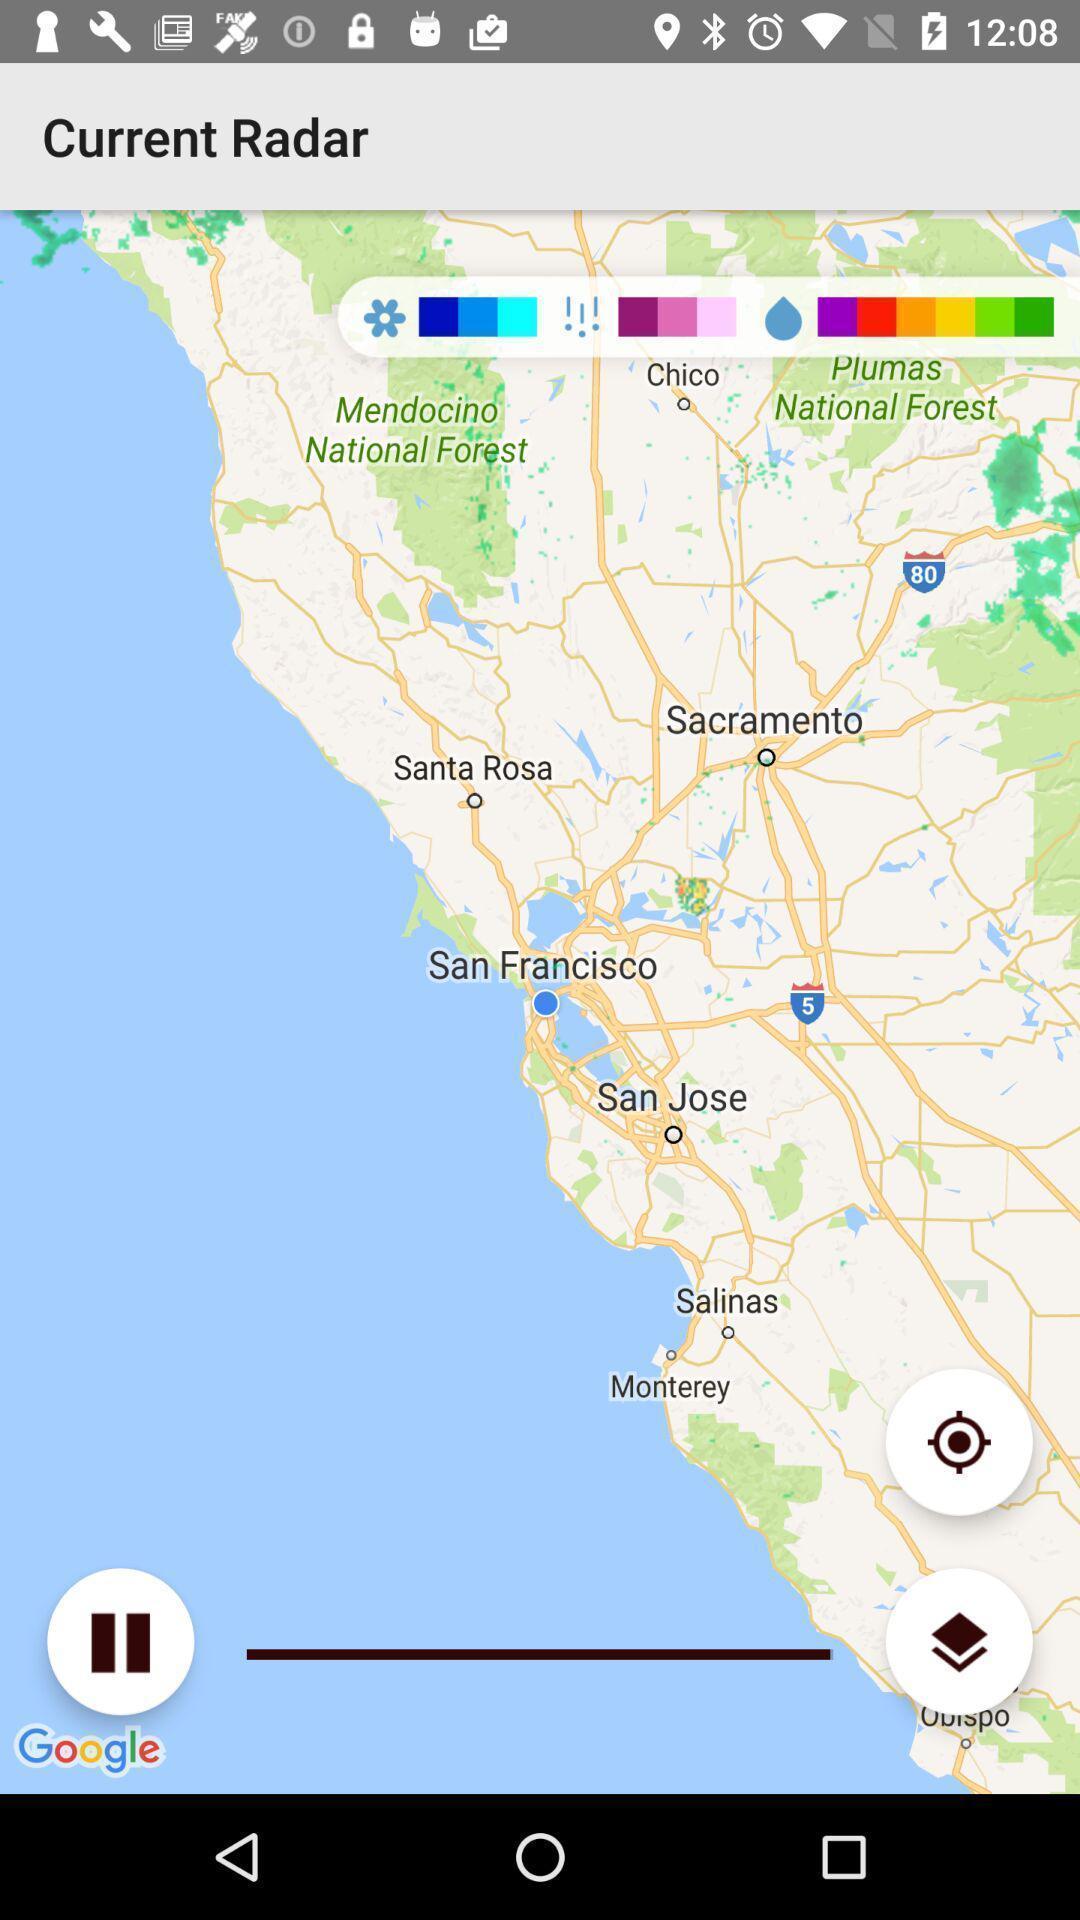Explain what's happening in this screen capture. Screen showing map. 